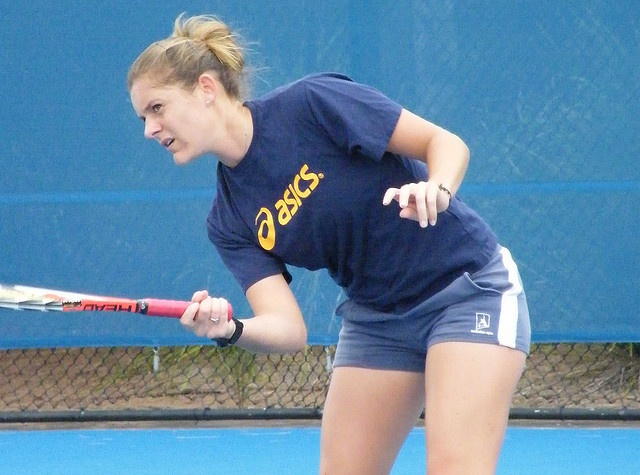Describe the objects in this image and their specific colors. I can see people in gray, navy, tan, and lightgray tones and tennis racket in gray, white, and salmon tones in this image. 